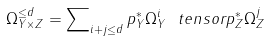Convert formula to latex. <formula><loc_0><loc_0><loc_500><loc_500>\Omega _ { Y \times Z } ^ { \leq d } = \sum \nolimits _ { i + j \leq d } p _ { Y } ^ { * } \Omega _ { Y } ^ { i } \ t e n s o r p _ { Z } ^ { * } \Omega _ { Z } ^ { j }</formula> 